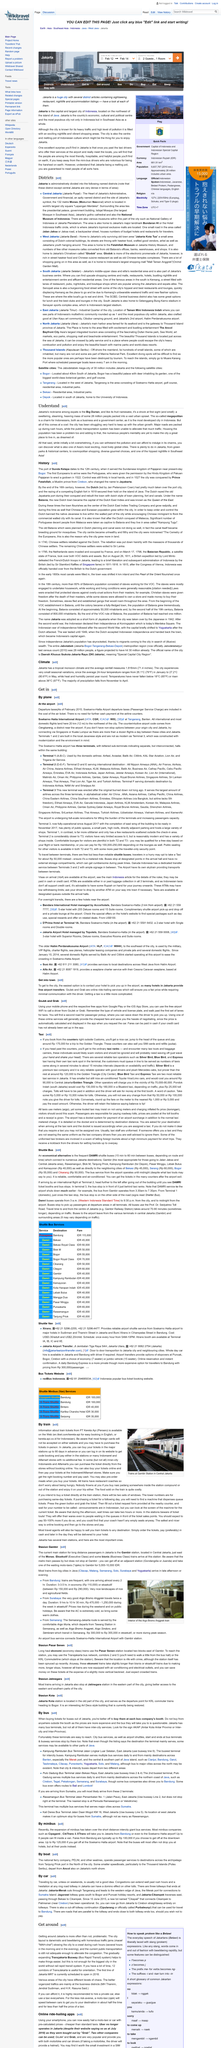Give some essential details in this illustration. According to the article "Understand Jakarta: The Realities and Challenges of Living in Indonesia's Capital," Jakarta is commonly referred to by expats as "Big Durian. Jakarta, the capital city of Indonesia, is located in the country of Indonesia. The city of Jakarta is home to approximately 28 million people, making it one of the most populous cities in the world. 